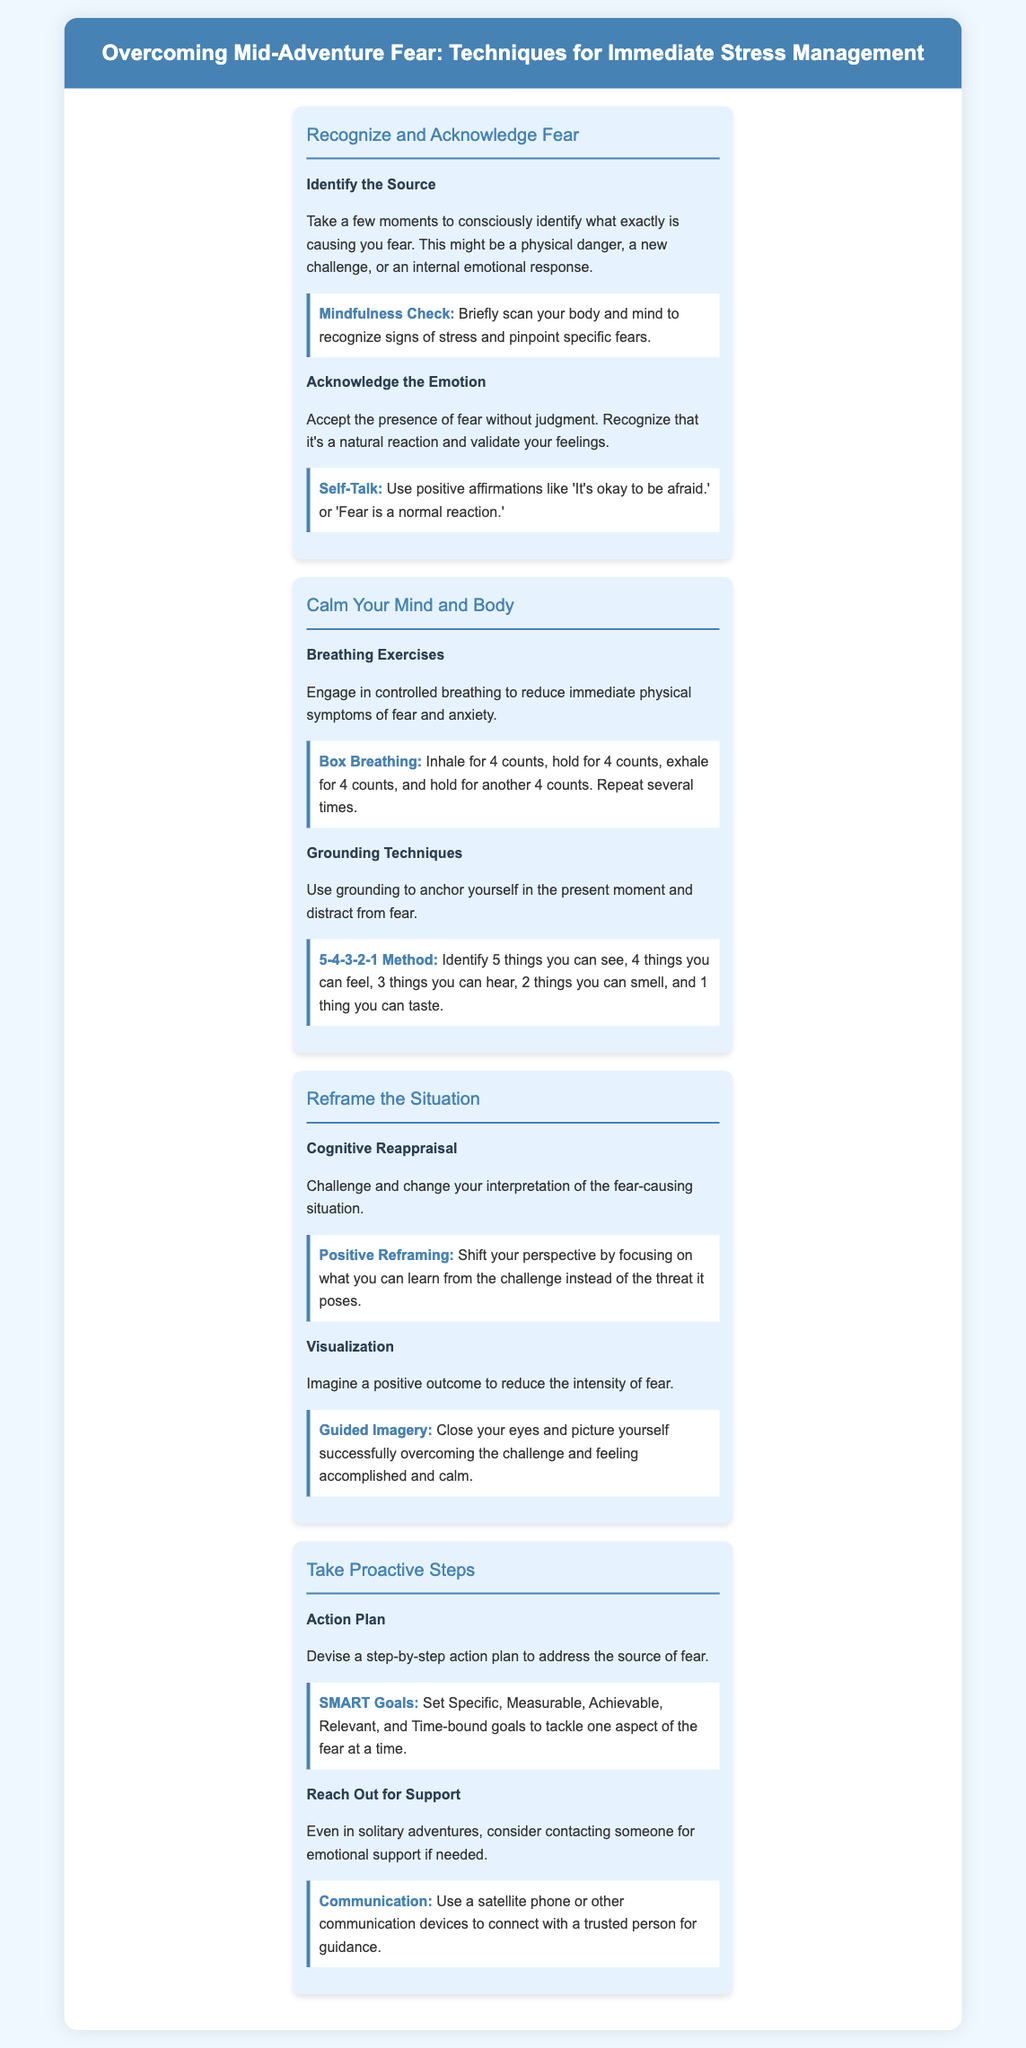what is the first step in overcoming mid-adventure fear? The first step is to recognize and acknowledge fear, which is emphasized in the infographic.
Answer: Recognize and Acknowledge Fear what technique can help with identifying the source of fear? The document mentions using a mindfulness check to recognize signs of stress and pinpoint specific fears.
Answer: Mindfulness Check how many breathing exercises are listed in the document? The document specifically lists two breathing techniques under calming the mind and body.
Answer: 2 what is a technique used for grounding? The document provides the 5-4-3-2-1 method as a grounding technique to anchor yourself in the present moment.
Answer: 5-4-3-2-1 Method what does the Positive Reframing technique involve? Positive Reframing involves shifting your perspective to focus on what you can learn from a challenge instead of the threat it poses.
Answer: Shift your perspective how many sections are there in the infographic? The infographic contains four sections that address different aspects of overcoming fear.
Answer: 4 what is the purpose of an Action Plan in overcoming fear? The purpose is to devise a step-by-step strategy to address the source of fear, as outlined in the document.
Answer: Step-by-step strategy what tool is suggested for communication when alone? The document suggests using a satellite phone or other communication devices to connect with a trusted person.
Answer: Satellite phone 